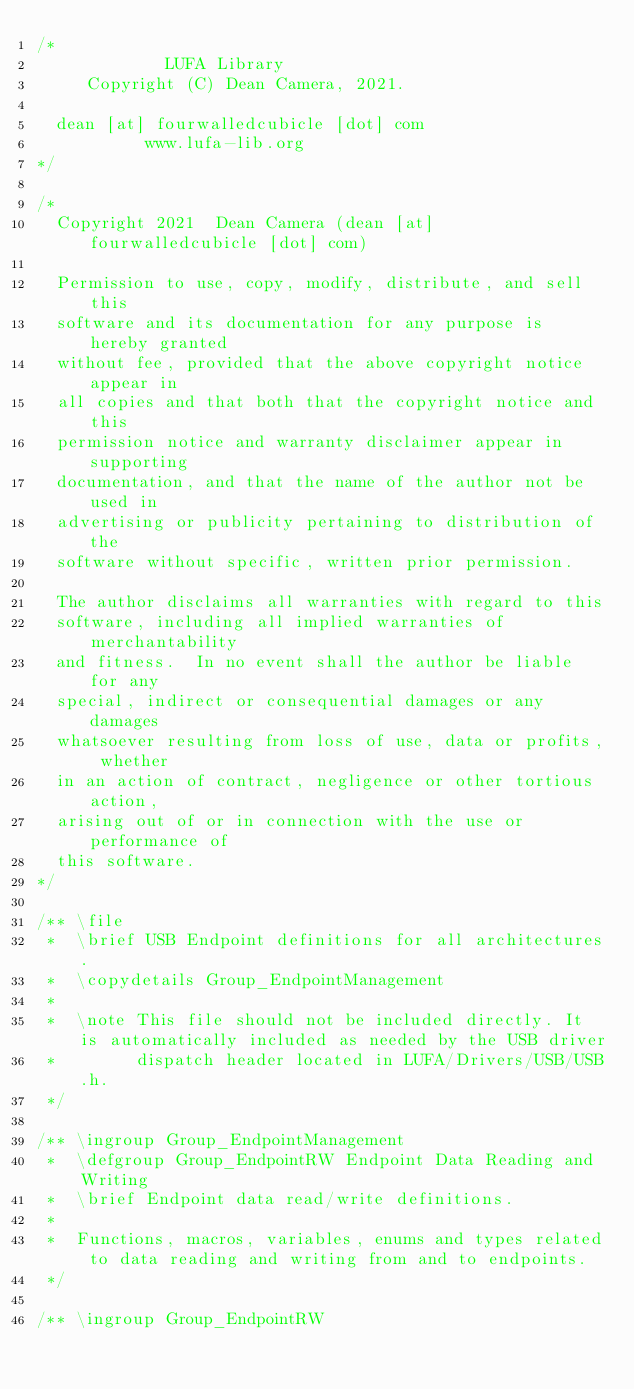Convert code to text. <code><loc_0><loc_0><loc_500><loc_500><_C_>/*
             LUFA Library
     Copyright (C) Dean Camera, 2021.

  dean [at] fourwalledcubicle [dot] com
           www.lufa-lib.org
*/

/*
  Copyright 2021  Dean Camera (dean [at] fourwalledcubicle [dot] com)

  Permission to use, copy, modify, distribute, and sell this
  software and its documentation for any purpose is hereby granted
  without fee, provided that the above copyright notice appear in
  all copies and that both that the copyright notice and this
  permission notice and warranty disclaimer appear in supporting
  documentation, and that the name of the author not be used in
  advertising or publicity pertaining to distribution of the
  software without specific, written prior permission.

  The author disclaims all warranties with regard to this
  software, including all implied warranties of merchantability
  and fitness.  In no event shall the author be liable for any
  special, indirect or consequential damages or any damages
  whatsoever resulting from loss of use, data or profits, whether
  in an action of contract, negligence or other tortious action,
  arising out of or in connection with the use or performance of
  this software.
*/

/** \file
 *  \brief USB Endpoint definitions for all architectures.
 *  \copydetails Group_EndpointManagement
 *
 *  \note This file should not be included directly. It is automatically included as needed by the USB driver
 *        dispatch header located in LUFA/Drivers/USB/USB.h.
 */

/** \ingroup Group_EndpointManagement
 *  \defgroup Group_EndpointRW Endpoint Data Reading and Writing
 *  \brief Endpoint data read/write definitions.
 *
 *  Functions, macros, variables, enums and types related to data reading and writing from and to endpoints.
 */

/** \ingroup Group_EndpointRW</code> 